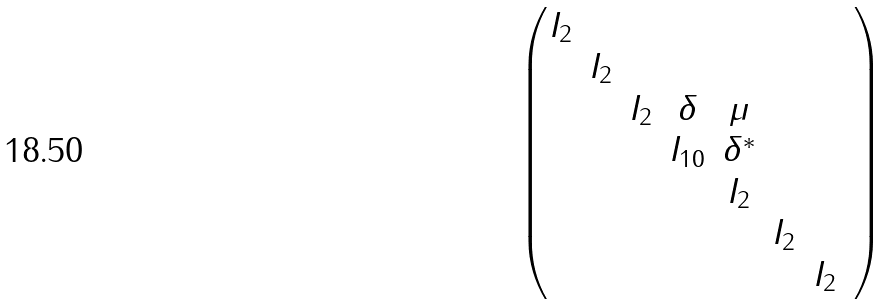Convert formula to latex. <formula><loc_0><loc_0><loc_500><loc_500>\begin{pmatrix} I _ { 2 } & & & & & & \\ & I _ { 2 } & & & & & & \\ & & I _ { 2 } & \delta & \mu & & \\ & & & I _ { 1 0 } & \delta ^ { * } & & \\ & & & & I _ { 2 } & & \\ & & & & & I _ { 2 } & \\ & & & & & & I _ { 2 } \end{pmatrix}</formula> 